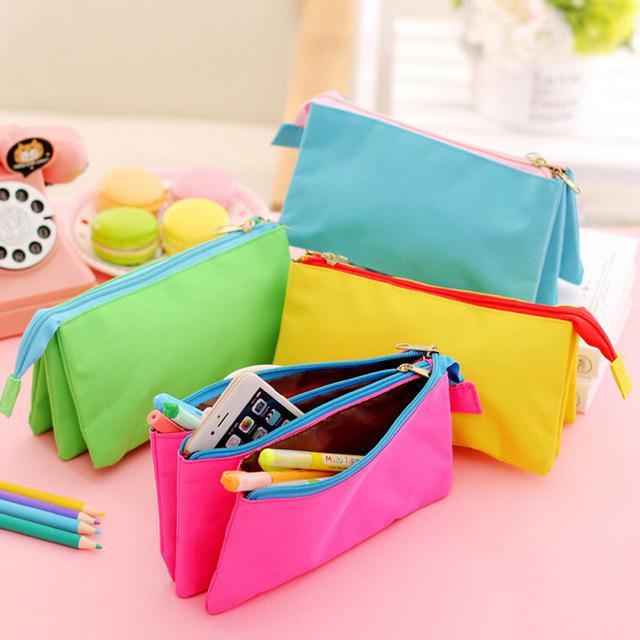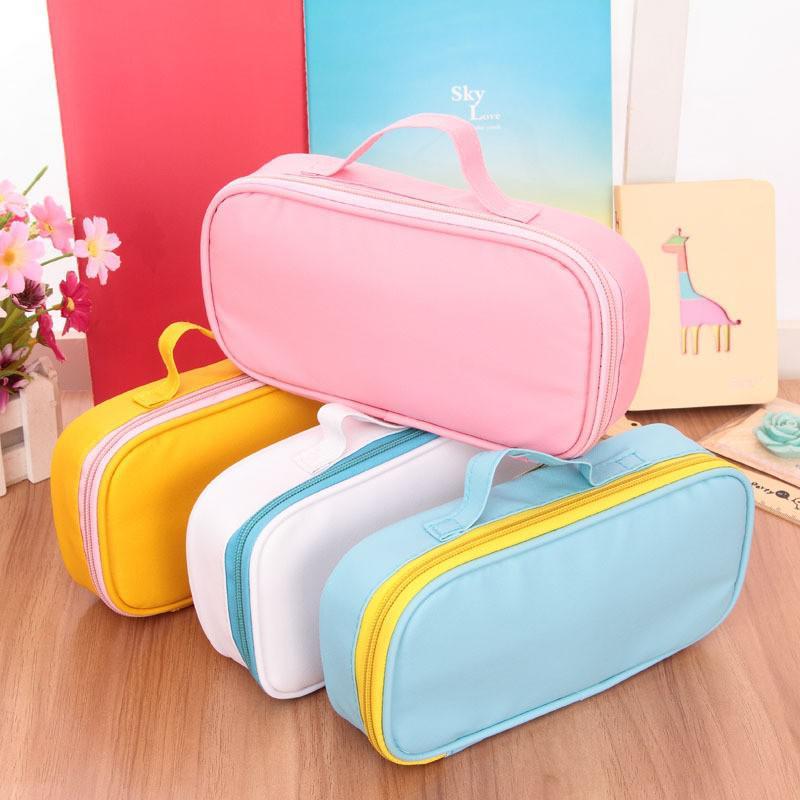The first image is the image on the left, the second image is the image on the right. Given the left and right images, does the statement "One image shows exactly four closed pencil cases of different solid colors, designed with zippers that extend around rounded corners." hold true? Answer yes or no. Yes. The first image is the image on the left, the second image is the image on the right. For the images shown, is this caption "Contents are poking out of one of the bags in the image on the left." true? Answer yes or no. Yes. 